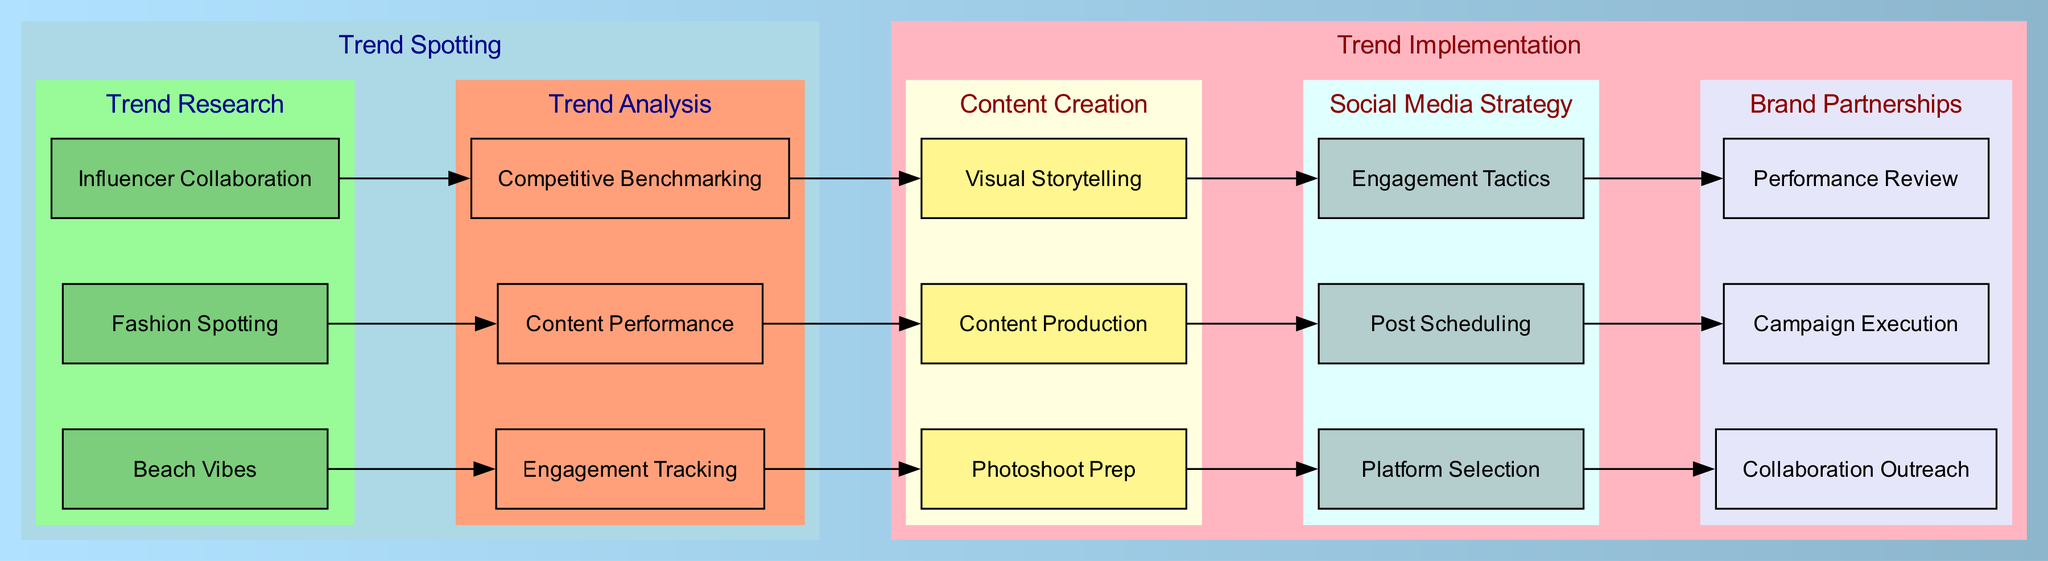What are the three beach vibes identified? The diagram lists Malibu, Tulum, and Mykonos under the "Beach Vibes" node. These are the specific locations mentioned as trending beach vibes.
Answer: Malibu, Tulum, Mykonos How many nodes are under Trend Research? By counting the nodes listed under "Trend Research," which are "Beach Vibes," "Fashion Spotting," and "Influencer Collaboration," we find a total of three nodes.
Answer: 3 Which node connects "Fashion Spotting" and "Content Performance"? The edge that connects "Fashion Spotting" to "Content Performance" indicates a flow from "Fashion Spotting," leading directly to "Content Performance." Thus, the connecting node is "Fashion Spotting."
Answer: Fashion Spotting What is the purpose of "Photoshoot Prep"? The "Photoshoot Prep" node falls under the "Content Creation" category, indicating that it involves preparation steps prior to creating content, such as outfit planning and location scouting.
Answer: Preparation Which node represents campaign evaluation? The "Performance Review" node is responsible for evaluating the success of campaigns, as indicated in the "Brand Partnerships" section of the diagram, focusing on assessing sales and engagement metrics.
Answer: Performance Review What is the relationship between "Content Performance" and "Content Production"? "Content Performance" flows into "Content Production," suggesting that the analysis of content performance informs the production stage, emphasizing a feedback cycle in the content creation process.
Answer: Informing Which platform is recommended for selection? The diagram highlights "Instagram" and "TikTok" as the platforms suggested for social media strategy, under "Platform Selection." The first listed platform is often prioritized for engagement.
Answer: Instagram How many engagement tactics are noted? Under the "Engagement Tactics" node, only two broad categories are mentioned—"Giveaways" and "Collaborations." This indicates that there are effectively two primary engagement tactics outlined.
Answer: 2 What is tracked in "Engagement Tracking"? The "Engagement Tracking" node monitors elements like "Like & Comment Analytics" and "Story Views," which provide insights into follower interaction and engagement with posts.
Answer: Interaction metrics 